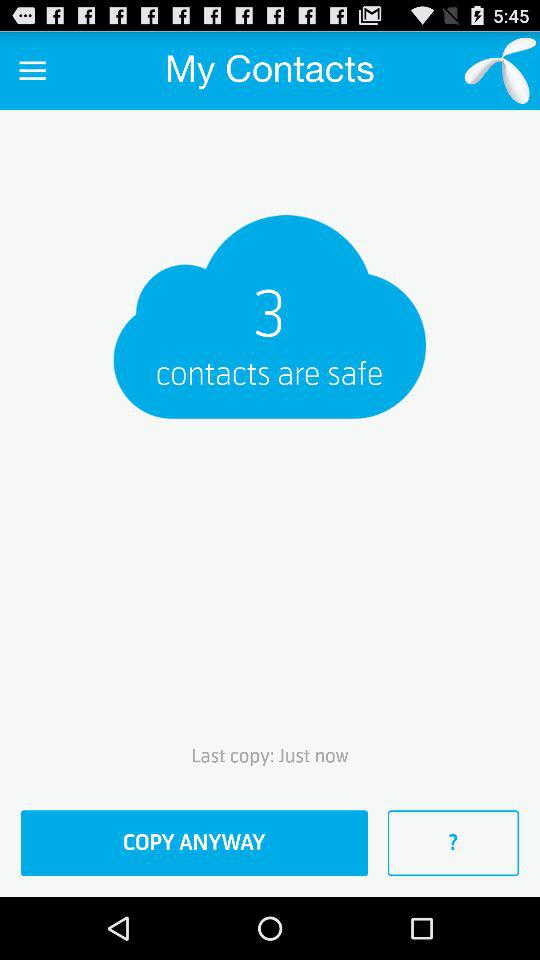How long ago was the last copy?
Answer the question using a single word or phrase. Just now 